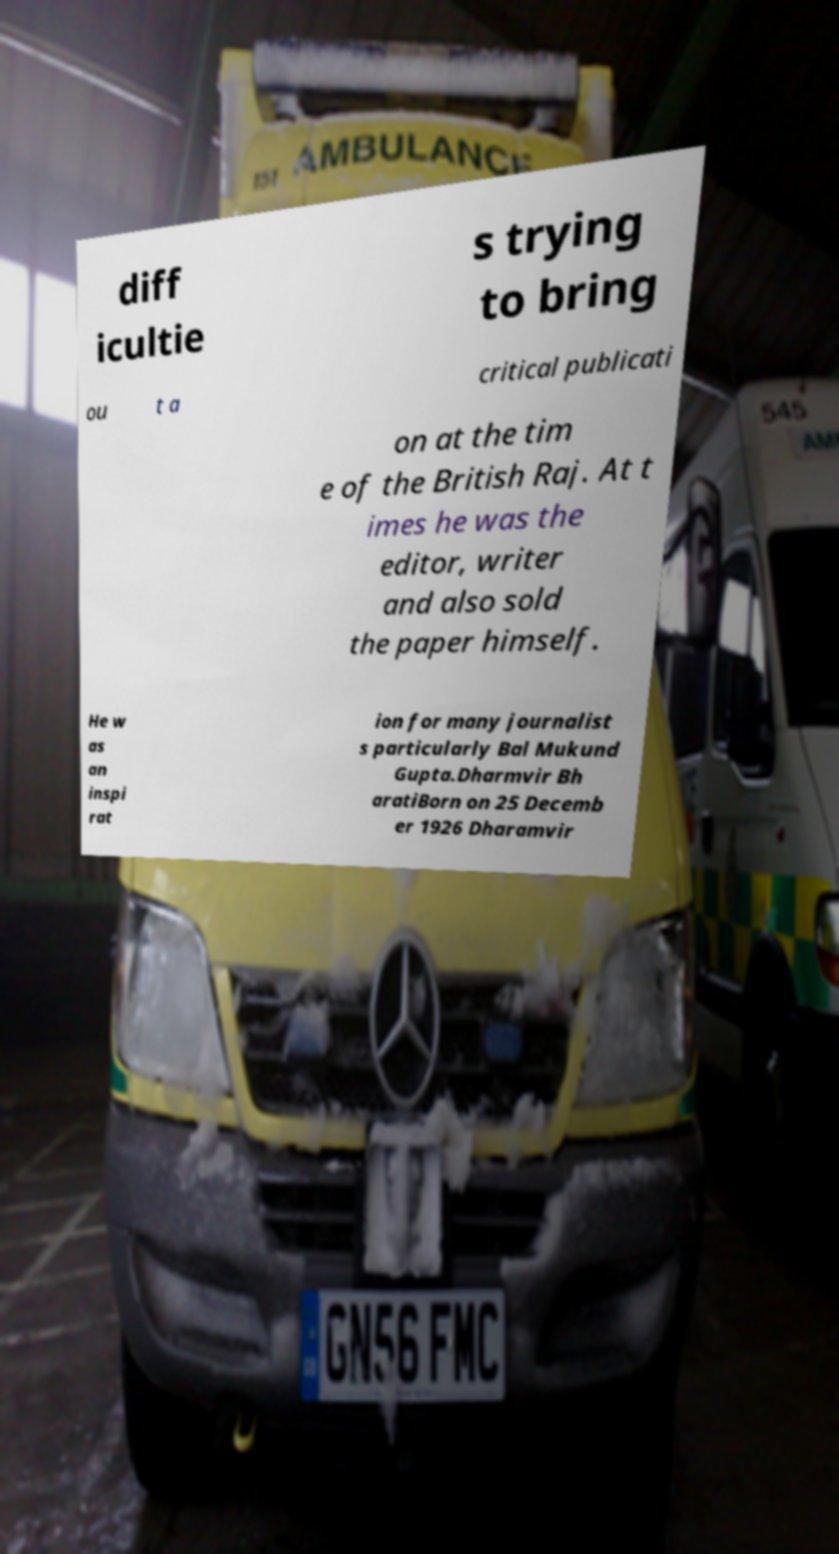I need the written content from this picture converted into text. Can you do that? diff icultie s trying to bring ou t a critical publicati on at the tim e of the British Raj. At t imes he was the editor, writer and also sold the paper himself. He w as an inspi rat ion for many journalist s particularly Bal Mukund Gupta.Dharmvir Bh aratiBorn on 25 Decemb er 1926 Dharamvir 